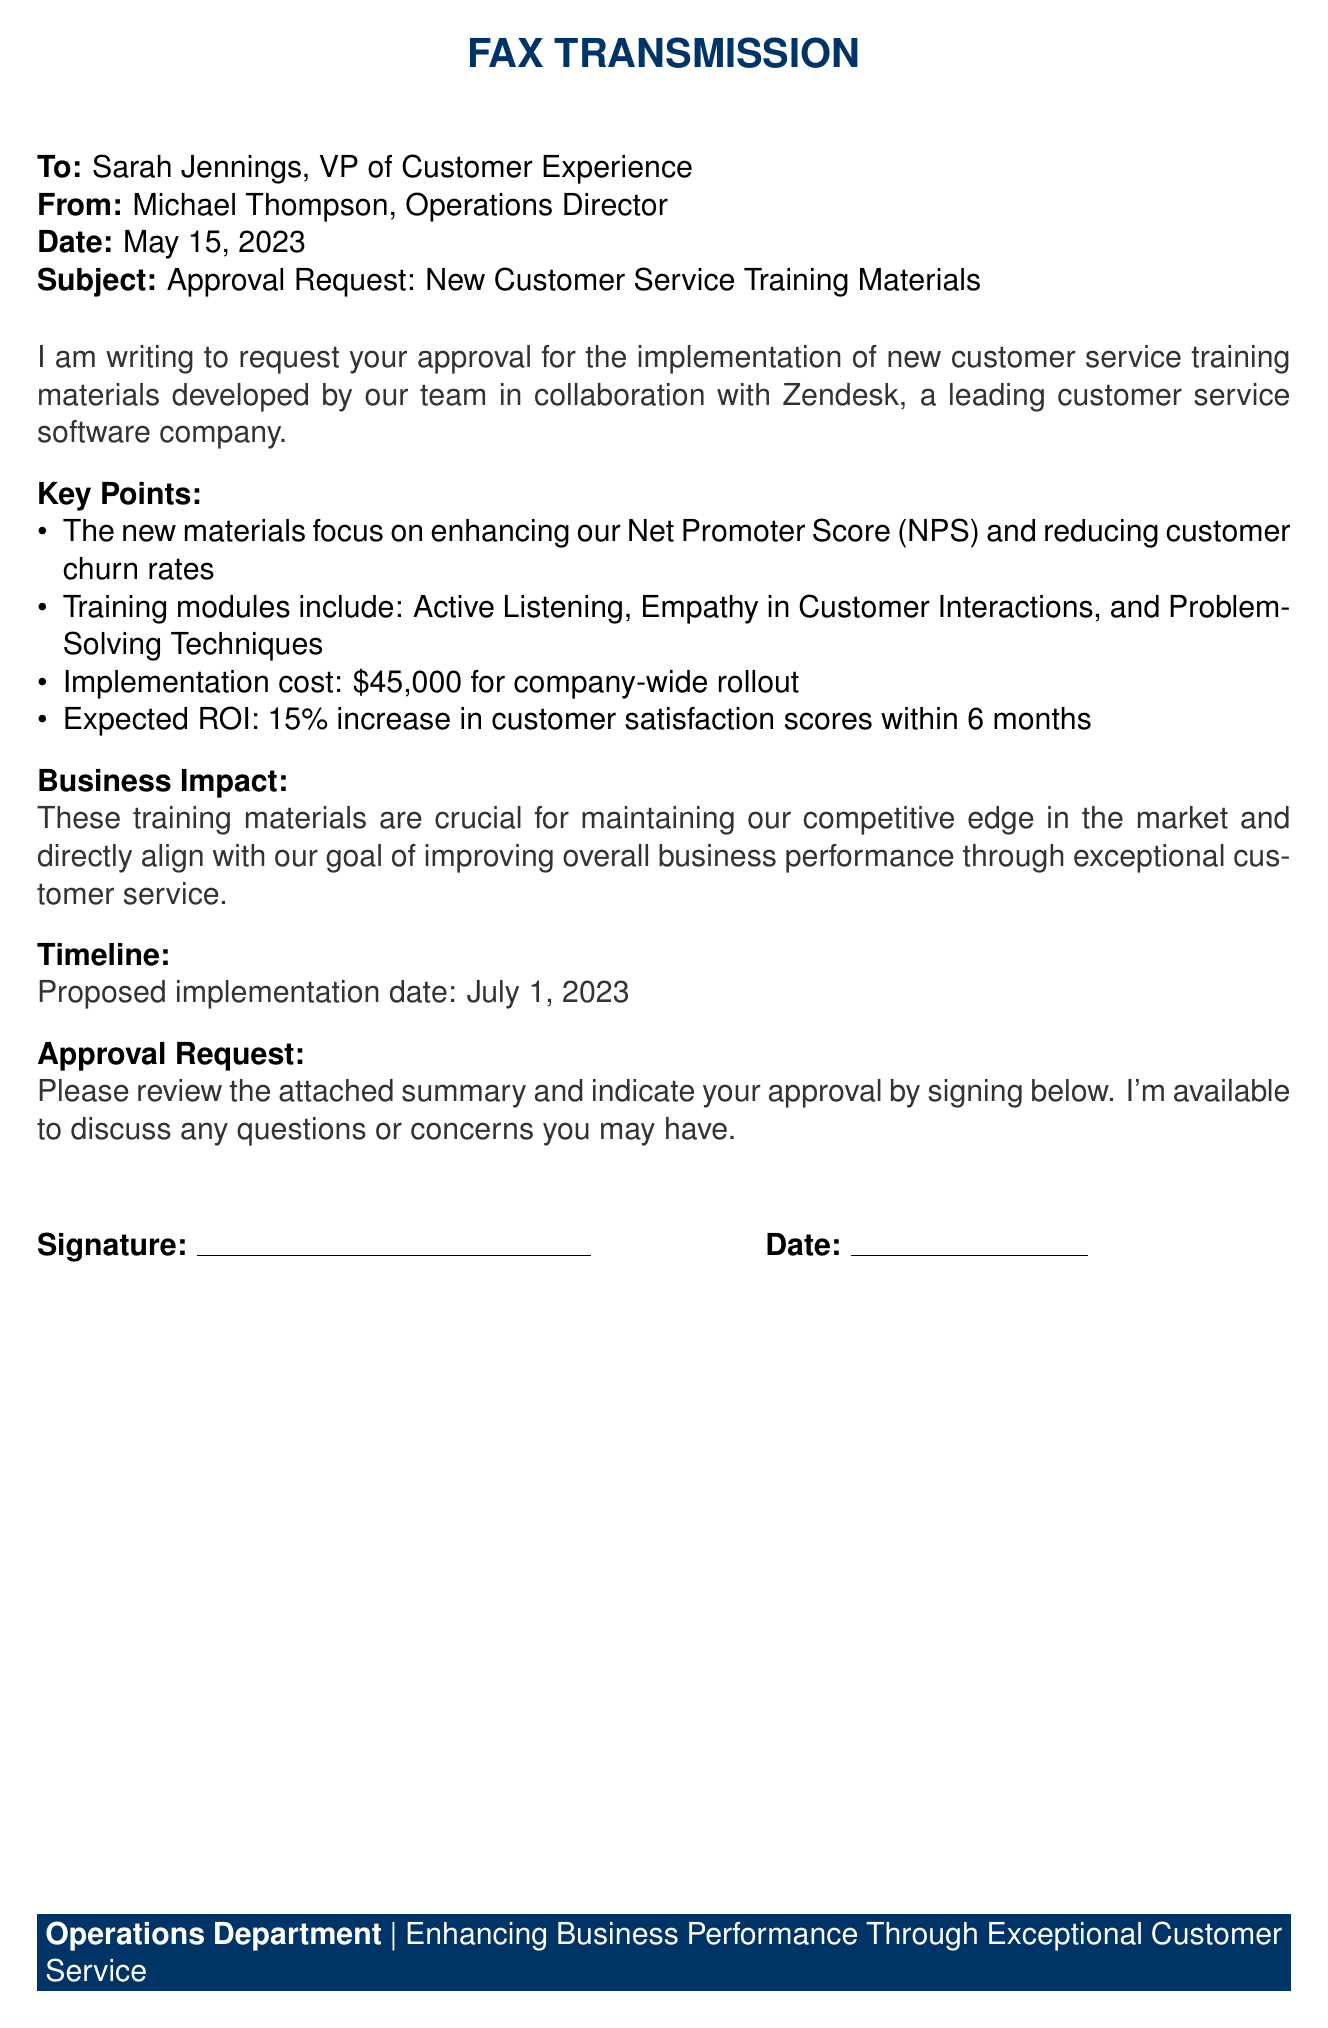What is the subject of the fax? The subject line clearly indicates the main topic of the fax, which is a request for approval.
Answer: Approval Request: New Customer Service Training Materials Who is the sender of the fax? The sender's details are provided at the beginning of the fax, clearly stating the name and title.
Answer: Michael Thompson, Operations Director What is the cost of the training implementation? The document specifies the cost that needs approval for implementing the training materials.
Answer: $45,000 What is the expected ROI after implementation? The document states the anticipated return on investment concerning customer satisfaction scores.
Answer: 15% increase When is the proposed implementation date? The timeline section mentions the planned start date for the training rollout.
Answer: July 1, 2023 What key module focuses on customer interactions? The key points highlight a specific training area aimed at enhancing how employees engage with customers.
Answer: Empathy in Customer Interactions What is the objective related to the Net Promoter Score? The document outlines an aim to improve metrics related to customer satisfaction and loyalty.
Answer: Enhancing our Net Promoter Score (NPS) Who is the recipient of the fax? The recipient's information is provided at the top of the fax, identifying the individual expected to approve the request.
Answer: Sarah Jennings, VP of Customer Experience 